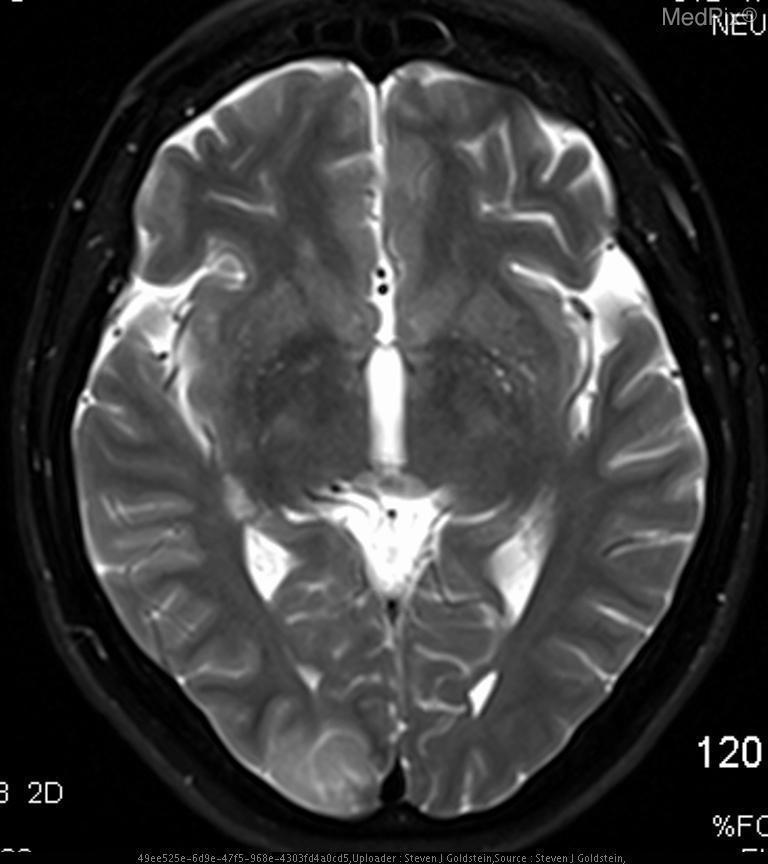What type of image modality is used?
Be succinct. Mri. Are the ventricles visualized in this image?
Be succinct. No. Are you able to see the ventricles in this image?
Be succinct. No. Is the pathology seen hyperintense or hypointense in nature?
Be succinct. Hyperintense. Is the abnormality hyperintense or hypointense?
Give a very brief answer. Hyperintense. The image shows what abnormality?
Be succinct. Abnormal hyperintensity in the right occipital lobe. What is abnormal in this image?
Keep it brief. Abnormal hyperintensity in the right occipital lobe. 